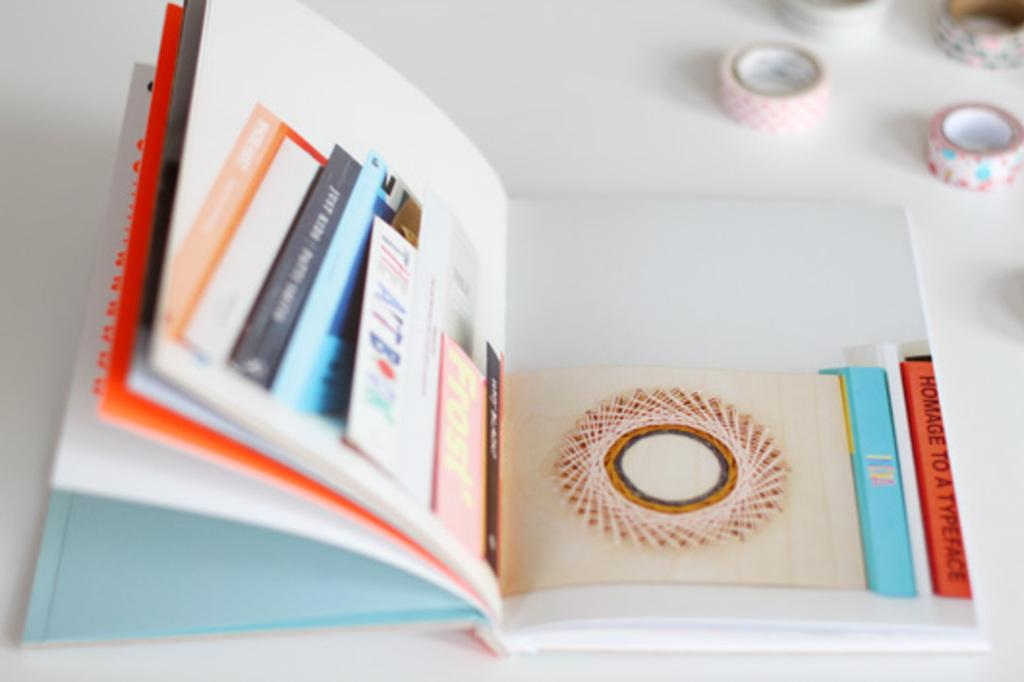What is the main object in the image? There is a book in the image. What type of objects are near the book? There are four round tapes in the image. What is the color of the surface where the objects are placed? The objects are on a white surface. What can be read on the book? There is text visible on the book. Are there any additional items on the book? A few objects are visible on the book. What type of root can be seen growing from the book in the image? There is no root growing from the book in the image. Is there a coat draped over the book in the image? There is no coat present in the image. 